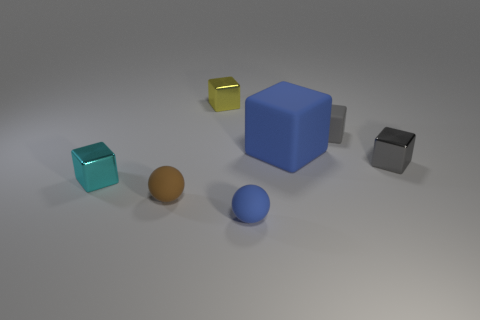Subtract all blue cubes. How many cubes are left? 4 Subtract all large blue cubes. How many cubes are left? 4 Subtract 1 cubes. How many cubes are left? 4 Subtract all red cubes. Subtract all red balls. How many cubes are left? 5 Add 3 big blue balls. How many objects exist? 10 Subtract all cubes. How many objects are left? 2 Subtract all small green rubber things. Subtract all matte balls. How many objects are left? 5 Add 4 brown balls. How many brown balls are left? 5 Add 2 small yellow cylinders. How many small yellow cylinders exist? 2 Subtract 0 cyan cylinders. How many objects are left? 7 